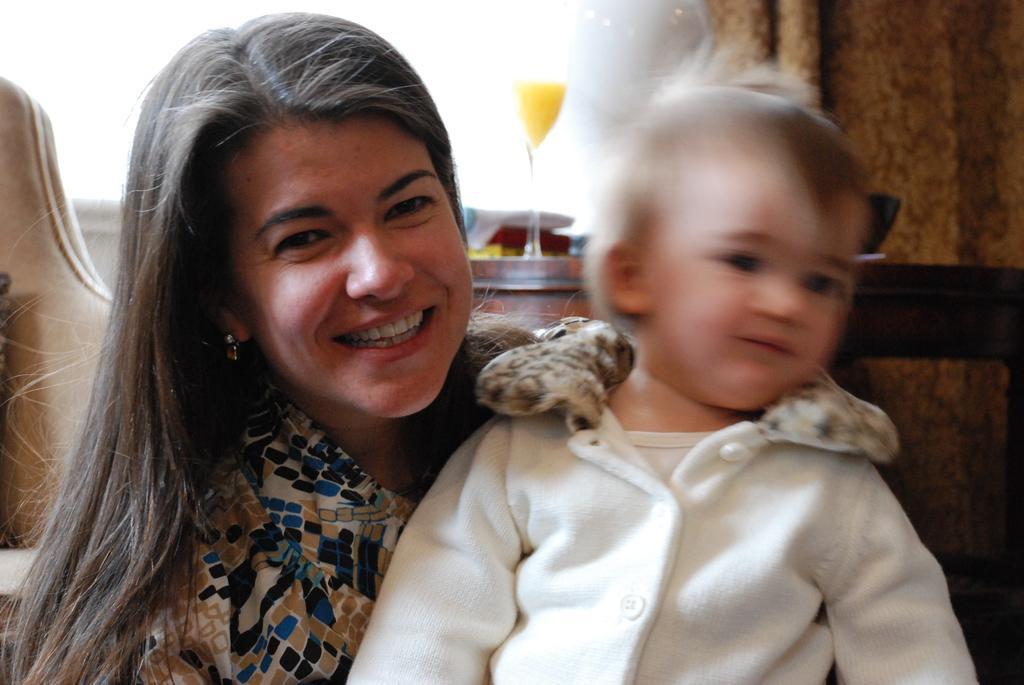Describe this image in one or two sentences. In this image I can see a woman and a boy. I can see smile on her face and here I can see he is wearing white colour dress. In the background I can see a glass and in it I can see yellow colour thing. 